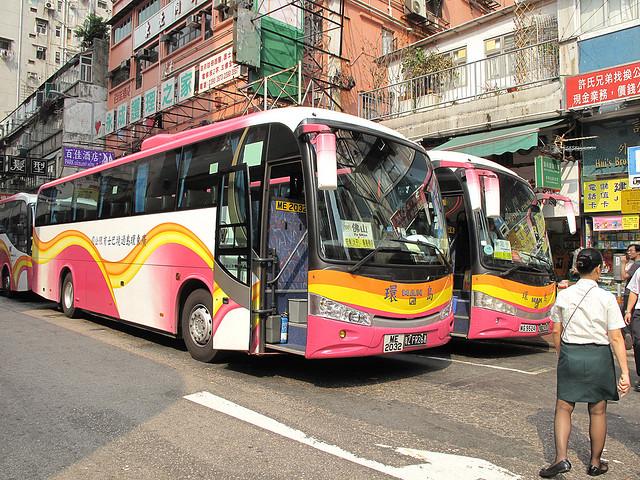Do the buses match?
Short answer required. Yes. Are the buses moving?
Concise answer only. No. Do the two buses match in color?
Give a very brief answer. Yes. 